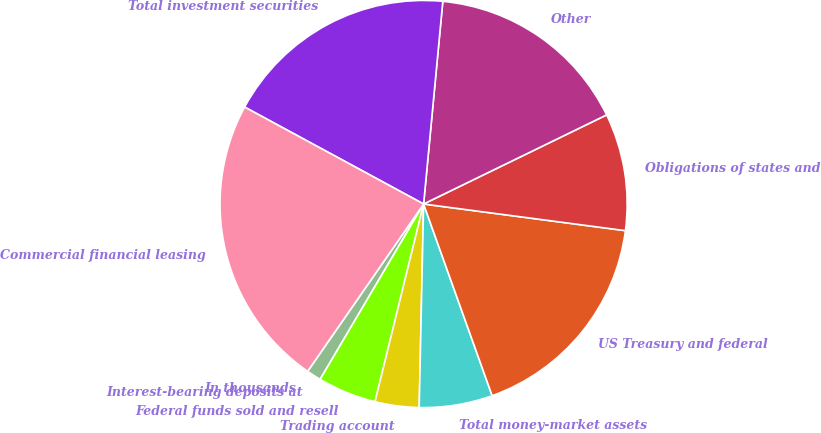Convert chart. <chart><loc_0><loc_0><loc_500><loc_500><pie_chart><fcel>In thousands<fcel>Interest-bearing deposits at<fcel>Federal funds sold and resell<fcel>Trading account<fcel>Total money-market assets<fcel>US Treasury and federal<fcel>Obligations of states and<fcel>Other<fcel>Total investment securities<fcel>Commercial financial leasing<nl><fcel>0.0%<fcel>1.16%<fcel>4.65%<fcel>3.49%<fcel>5.81%<fcel>17.44%<fcel>9.3%<fcel>16.28%<fcel>18.6%<fcel>23.25%<nl></chart> 